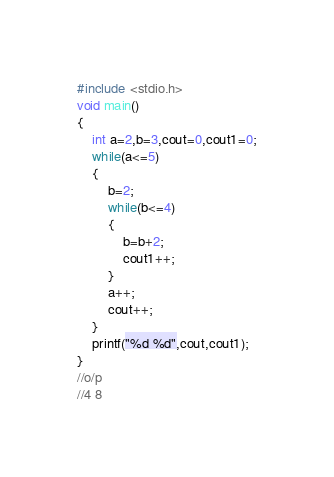<code> <loc_0><loc_0><loc_500><loc_500><_C_>#include <stdio.h>
void main()
{
    int a=2,b=3,cout=0,cout1=0;
    while(a<=5)
    {
        b=2;
        while(b<=4)
        {
            b=b+2;
            cout1++;
        }
        a++;
        cout++;
    }
    printf("%d %d",cout,cout1);
}
//o/p
//4 8
</code> 